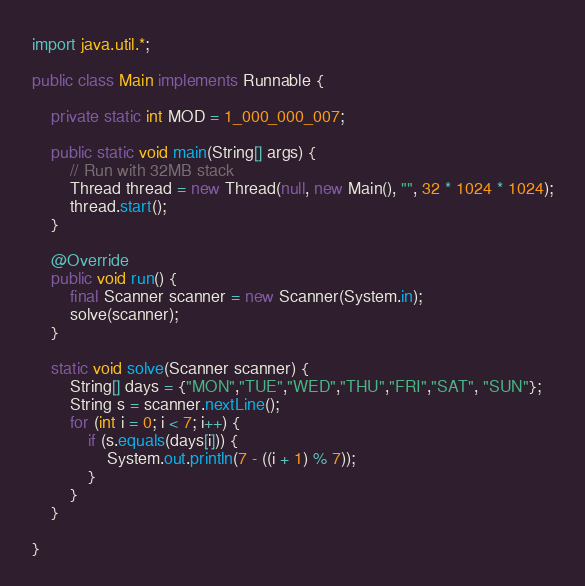Convert code to text. <code><loc_0><loc_0><loc_500><loc_500><_Java_>import java.util.*;

public class Main implements Runnable {

    private static int MOD = 1_000_000_007;

    public static void main(String[] args) {
        // Run with 32MB stack
        Thread thread = new Thread(null, new Main(), "", 32 * 1024 * 1024);
        thread.start();
    }

    @Override
    public void run() {
        final Scanner scanner = new Scanner(System.in);
        solve(scanner);
    }

    static void solve(Scanner scanner) {
        String[] days = {"MON","TUE","WED","THU","FRI","SAT", "SUN"};
        String s = scanner.nextLine();
        for (int i = 0; i < 7; i++) {
            if (s.equals(days[i])) {
                System.out.println(7 - ((i + 1) % 7));
            }
        }
    }

}

</code> 